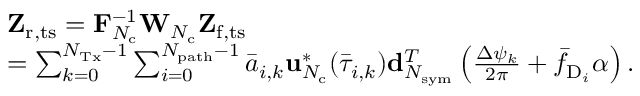<formula> <loc_0><loc_0><loc_500><loc_500>\begin{array} { r l } & { Z _ { r , t s } = F _ { N _ { c } } ^ { - 1 } W _ { N _ { c } } Z _ { f , t s } } \\ & { = \sum _ { k = 0 } ^ { N _ { T x } - 1 } \sum _ { i = 0 } ^ { N _ { p a t h } - 1 } \bar { a } _ { i , k } u _ { N _ { c } } ^ { * } ( \bar { \tau } _ { i , k } ) d _ { N _ { s y m } } ^ { T } \left ( \frac { \Delta \psi _ { k } } { 2 \pi } + \bar { f } _ { D _ { i } } \alpha \right ) . } \end{array}</formula> 